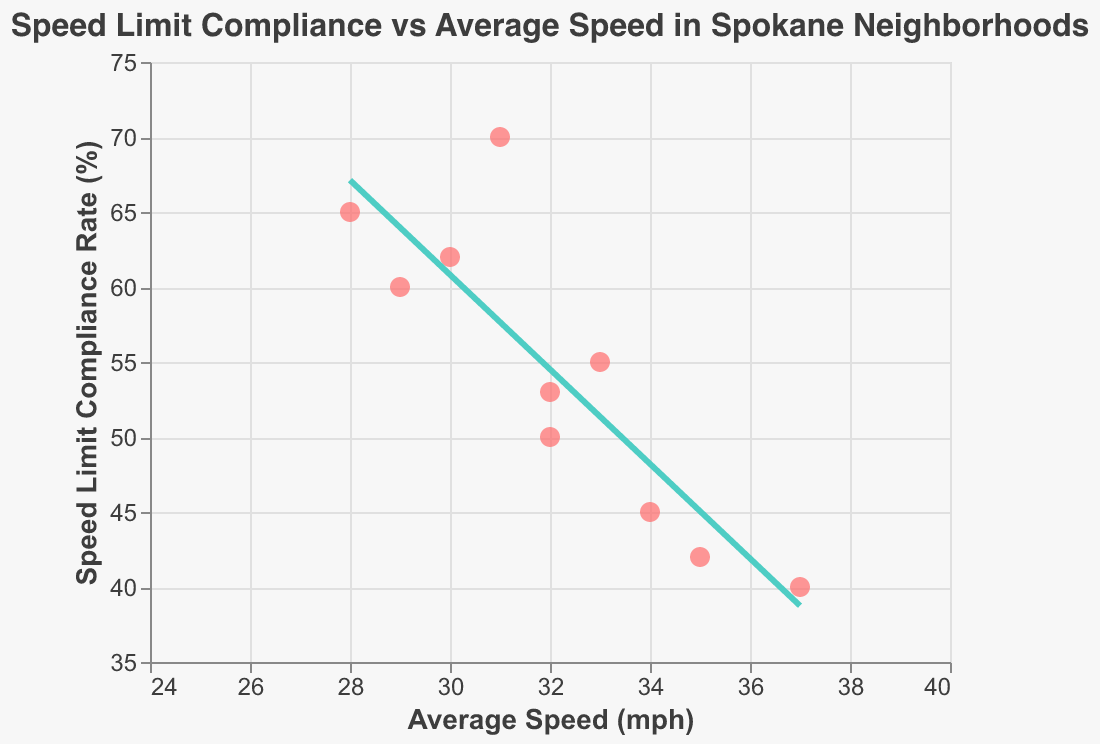What's the title of the plot? The title is located at the top center of the plot in a larger font size and distinct color. It reads: "Speed Limit Compliance vs Average Speed in Spokane Neighborhoods".
Answer: Speed Limit Compliance vs Average Speed in Spokane Neighborhoods Which neighborhood has the lowest average speed? The neighborhood with the lowest average speed will be the one with the leftmost point on the x-axis. Vinegar Flats, with an average speed of 28 mph, has the lowest average speed.
Answer: Vinegar Flats What is the speed limit compliance rate for Central Spokane? Hovering over the point representing Central Spokane or locating it on the y-axis reveals that the speed limit compliance rate is 45%.
Answer: 45% What is the average speed and speed limit compliance rate of neighborhood Hillyard? Hovering over the point representing Hillyard or locating it on the plot shows the average speed to be 35 mph and the speed limit compliance rate to be 42%.
Answer: 35 mph, 42% Which neighborhood has the highest speed limit compliance rate? By examining the plot and identifying the highest point along the y-axis, Liberty Lake has the highest speed limit compliance rate at 70%.
Answer: Liberty Lake How does South Hill's average speed compare to West Spokane's? South Hill's average speed is 29 mph, while West Spokane's is 33 mph. Therefore, South Hill's average speed is lower.
Answer: South Hill's speed is lower Are there any neighborhoods with both average speed above 34 mph and compliance rate less than 45%? Checking the plot for points above 34 mph on the x-axis and below 45% on the y-axis, East Central meets these criteria with an average speed of 37 mph and a speed limit compliance rate of 40%.
Answer: East Central What is the trend shown by the trend line in the scatter plot? The trend line is slightly declining, suggesting a negative correlation between average speed and speed limit compliance rate. As the average speed increases, the compliance rate tends to decrease.
Answer: Negative correlation Which neighborhood has a higher speed limit compliance rate, Five Mile or Shadle Park? Five Mile has a speed limit compliance rate of 62%, whereas Shadle Park has 53%. Hence, Five Mile has a higher compliance rate.
Answer: Five Mile What does the color difference in the scatter plot represent? The scatter plot uses a uniform color for points and a different color for the trend line. The points are red (#ff6b6b), and the trend line is teal (#4ecdc4), making it clear that the color distinction helps differentiate data points from the trend line.
Answer: Distinguishes data points from trend line 